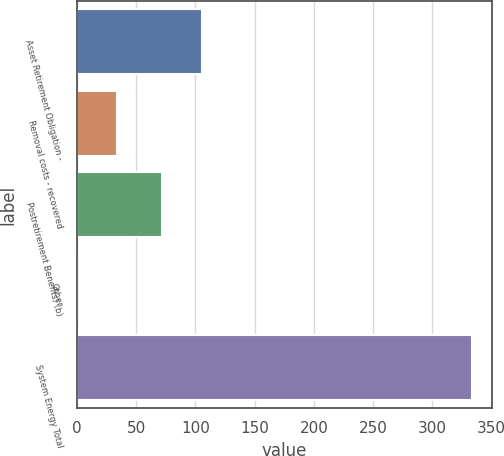Convert chart. <chart><loc_0><loc_0><loc_500><loc_500><bar_chart><fcel>Asset Retirement Obligation -<fcel>Removal costs - recovered<fcel>Postretirement Benefits) (b)<fcel>Other<fcel>System Energy Total<nl><fcel>105.4<fcel>33.7<fcel>72.1<fcel>0.4<fcel>333.4<nl></chart> 